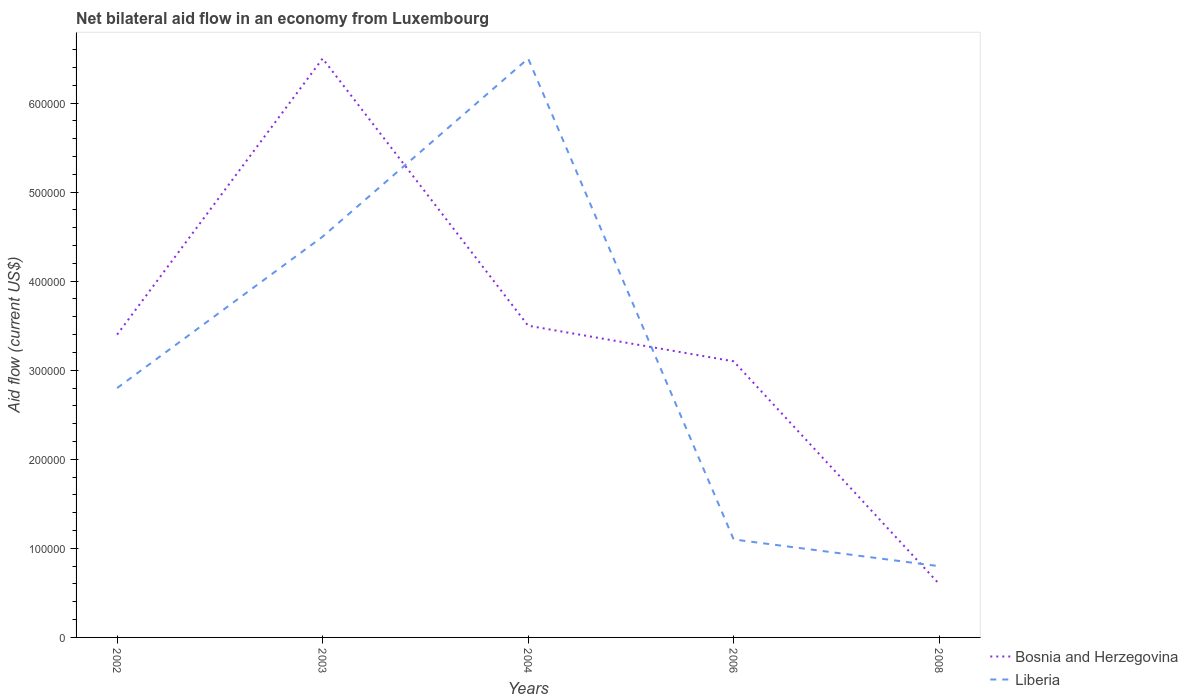How many different coloured lines are there?
Your answer should be compact. 2. Does the line corresponding to Bosnia and Herzegovina intersect with the line corresponding to Liberia?
Offer a very short reply. Yes. Is the number of lines equal to the number of legend labels?
Provide a short and direct response. Yes. Across all years, what is the maximum net bilateral aid flow in Bosnia and Herzegovina?
Your answer should be compact. 6.00e+04. What is the total net bilateral aid flow in Liberia in the graph?
Keep it short and to the point. 5.40e+05. What is the difference between the highest and the second highest net bilateral aid flow in Bosnia and Herzegovina?
Ensure brevity in your answer.  5.90e+05. What is the difference between the highest and the lowest net bilateral aid flow in Liberia?
Make the answer very short. 2. What is the difference between two consecutive major ticks on the Y-axis?
Ensure brevity in your answer.  1.00e+05. Are the values on the major ticks of Y-axis written in scientific E-notation?
Ensure brevity in your answer.  No. Does the graph contain grids?
Keep it short and to the point. No. What is the title of the graph?
Make the answer very short. Net bilateral aid flow in an economy from Luxembourg. Does "Congo (Republic)" appear as one of the legend labels in the graph?
Your answer should be very brief. No. What is the label or title of the Y-axis?
Your answer should be very brief. Aid flow (current US$). What is the Aid flow (current US$) of Bosnia and Herzegovina in 2003?
Offer a very short reply. 6.50e+05. What is the Aid flow (current US$) in Liberia in 2003?
Make the answer very short. 4.50e+05. What is the Aid flow (current US$) of Liberia in 2004?
Provide a short and direct response. 6.50e+05. What is the Aid flow (current US$) of Bosnia and Herzegovina in 2006?
Ensure brevity in your answer.  3.10e+05. What is the Aid flow (current US$) in Bosnia and Herzegovina in 2008?
Offer a terse response. 6.00e+04. Across all years, what is the maximum Aid flow (current US$) of Bosnia and Herzegovina?
Ensure brevity in your answer.  6.50e+05. Across all years, what is the maximum Aid flow (current US$) of Liberia?
Provide a succinct answer. 6.50e+05. Across all years, what is the minimum Aid flow (current US$) of Bosnia and Herzegovina?
Your answer should be very brief. 6.00e+04. Across all years, what is the minimum Aid flow (current US$) of Liberia?
Your answer should be very brief. 8.00e+04. What is the total Aid flow (current US$) in Bosnia and Herzegovina in the graph?
Keep it short and to the point. 1.71e+06. What is the total Aid flow (current US$) in Liberia in the graph?
Keep it short and to the point. 1.57e+06. What is the difference between the Aid flow (current US$) of Bosnia and Herzegovina in 2002 and that in 2003?
Provide a succinct answer. -3.10e+05. What is the difference between the Aid flow (current US$) of Liberia in 2002 and that in 2003?
Your answer should be compact. -1.70e+05. What is the difference between the Aid flow (current US$) of Liberia in 2002 and that in 2004?
Offer a terse response. -3.70e+05. What is the difference between the Aid flow (current US$) in Liberia in 2003 and that in 2004?
Offer a terse response. -2.00e+05. What is the difference between the Aid flow (current US$) in Bosnia and Herzegovina in 2003 and that in 2008?
Offer a terse response. 5.90e+05. What is the difference between the Aid flow (current US$) of Liberia in 2004 and that in 2006?
Your answer should be very brief. 5.40e+05. What is the difference between the Aid flow (current US$) of Liberia in 2004 and that in 2008?
Ensure brevity in your answer.  5.70e+05. What is the difference between the Aid flow (current US$) in Liberia in 2006 and that in 2008?
Your answer should be very brief. 3.00e+04. What is the difference between the Aid flow (current US$) of Bosnia and Herzegovina in 2002 and the Aid flow (current US$) of Liberia in 2003?
Your answer should be compact. -1.10e+05. What is the difference between the Aid flow (current US$) of Bosnia and Herzegovina in 2002 and the Aid flow (current US$) of Liberia in 2004?
Ensure brevity in your answer.  -3.10e+05. What is the difference between the Aid flow (current US$) in Bosnia and Herzegovina in 2002 and the Aid flow (current US$) in Liberia in 2006?
Give a very brief answer. 2.30e+05. What is the difference between the Aid flow (current US$) of Bosnia and Herzegovina in 2003 and the Aid flow (current US$) of Liberia in 2004?
Provide a succinct answer. 0. What is the difference between the Aid flow (current US$) of Bosnia and Herzegovina in 2003 and the Aid flow (current US$) of Liberia in 2006?
Your answer should be compact. 5.40e+05. What is the difference between the Aid flow (current US$) of Bosnia and Herzegovina in 2003 and the Aid flow (current US$) of Liberia in 2008?
Give a very brief answer. 5.70e+05. What is the difference between the Aid flow (current US$) of Bosnia and Herzegovina in 2004 and the Aid flow (current US$) of Liberia in 2006?
Offer a very short reply. 2.40e+05. What is the difference between the Aid flow (current US$) in Bosnia and Herzegovina in 2004 and the Aid flow (current US$) in Liberia in 2008?
Your answer should be compact. 2.70e+05. What is the difference between the Aid flow (current US$) in Bosnia and Herzegovina in 2006 and the Aid flow (current US$) in Liberia in 2008?
Your answer should be very brief. 2.30e+05. What is the average Aid flow (current US$) of Bosnia and Herzegovina per year?
Your answer should be compact. 3.42e+05. What is the average Aid flow (current US$) of Liberia per year?
Give a very brief answer. 3.14e+05. In the year 2006, what is the difference between the Aid flow (current US$) in Bosnia and Herzegovina and Aid flow (current US$) in Liberia?
Provide a succinct answer. 2.00e+05. In the year 2008, what is the difference between the Aid flow (current US$) in Bosnia and Herzegovina and Aid flow (current US$) in Liberia?
Provide a succinct answer. -2.00e+04. What is the ratio of the Aid flow (current US$) of Bosnia and Herzegovina in 2002 to that in 2003?
Offer a very short reply. 0.52. What is the ratio of the Aid flow (current US$) in Liberia in 2002 to that in 2003?
Make the answer very short. 0.62. What is the ratio of the Aid flow (current US$) in Bosnia and Herzegovina in 2002 to that in 2004?
Make the answer very short. 0.97. What is the ratio of the Aid flow (current US$) of Liberia in 2002 to that in 2004?
Give a very brief answer. 0.43. What is the ratio of the Aid flow (current US$) in Bosnia and Herzegovina in 2002 to that in 2006?
Provide a short and direct response. 1.1. What is the ratio of the Aid flow (current US$) in Liberia in 2002 to that in 2006?
Your answer should be compact. 2.55. What is the ratio of the Aid flow (current US$) in Bosnia and Herzegovina in 2002 to that in 2008?
Give a very brief answer. 5.67. What is the ratio of the Aid flow (current US$) of Bosnia and Herzegovina in 2003 to that in 2004?
Offer a very short reply. 1.86. What is the ratio of the Aid flow (current US$) of Liberia in 2003 to that in 2004?
Make the answer very short. 0.69. What is the ratio of the Aid flow (current US$) in Bosnia and Herzegovina in 2003 to that in 2006?
Make the answer very short. 2.1. What is the ratio of the Aid flow (current US$) of Liberia in 2003 to that in 2006?
Your answer should be very brief. 4.09. What is the ratio of the Aid flow (current US$) in Bosnia and Herzegovina in 2003 to that in 2008?
Your answer should be compact. 10.83. What is the ratio of the Aid flow (current US$) of Liberia in 2003 to that in 2008?
Your answer should be compact. 5.62. What is the ratio of the Aid flow (current US$) of Bosnia and Herzegovina in 2004 to that in 2006?
Give a very brief answer. 1.13. What is the ratio of the Aid flow (current US$) in Liberia in 2004 to that in 2006?
Give a very brief answer. 5.91. What is the ratio of the Aid flow (current US$) of Bosnia and Herzegovina in 2004 to that in 2008?
Your response must be concise. 5.83. What is the ratio of the Aid flow (current US$) in Liberia in 2004 to that in 2008?
Offer a very short reply. 8.12. What is the ratio of the Aid flow (current US$) of Bosnia and Herzegovina in 2006 to that in 2008?
Your response must be concise. 5.17. What is the ratio of the Aid flow (current US$) of Liberia in 2006 to that in 2008?
Offer a terse response. 1.38. What is the difference between the highest and the second highest Aid flow (current US$) of Bosnia and Herzegovina?
Offer a terse response. 3.00e+05. What is the difference between the highest and the lowest Aid flow (current US$) of Bosnia and Herzegovina?
Your answer should be compact. 5.90e+05. What is the difference between the highest and the lowest Aid flow (current US$) of Liberia?
Provide a short and direct response. 5.70e+05. 